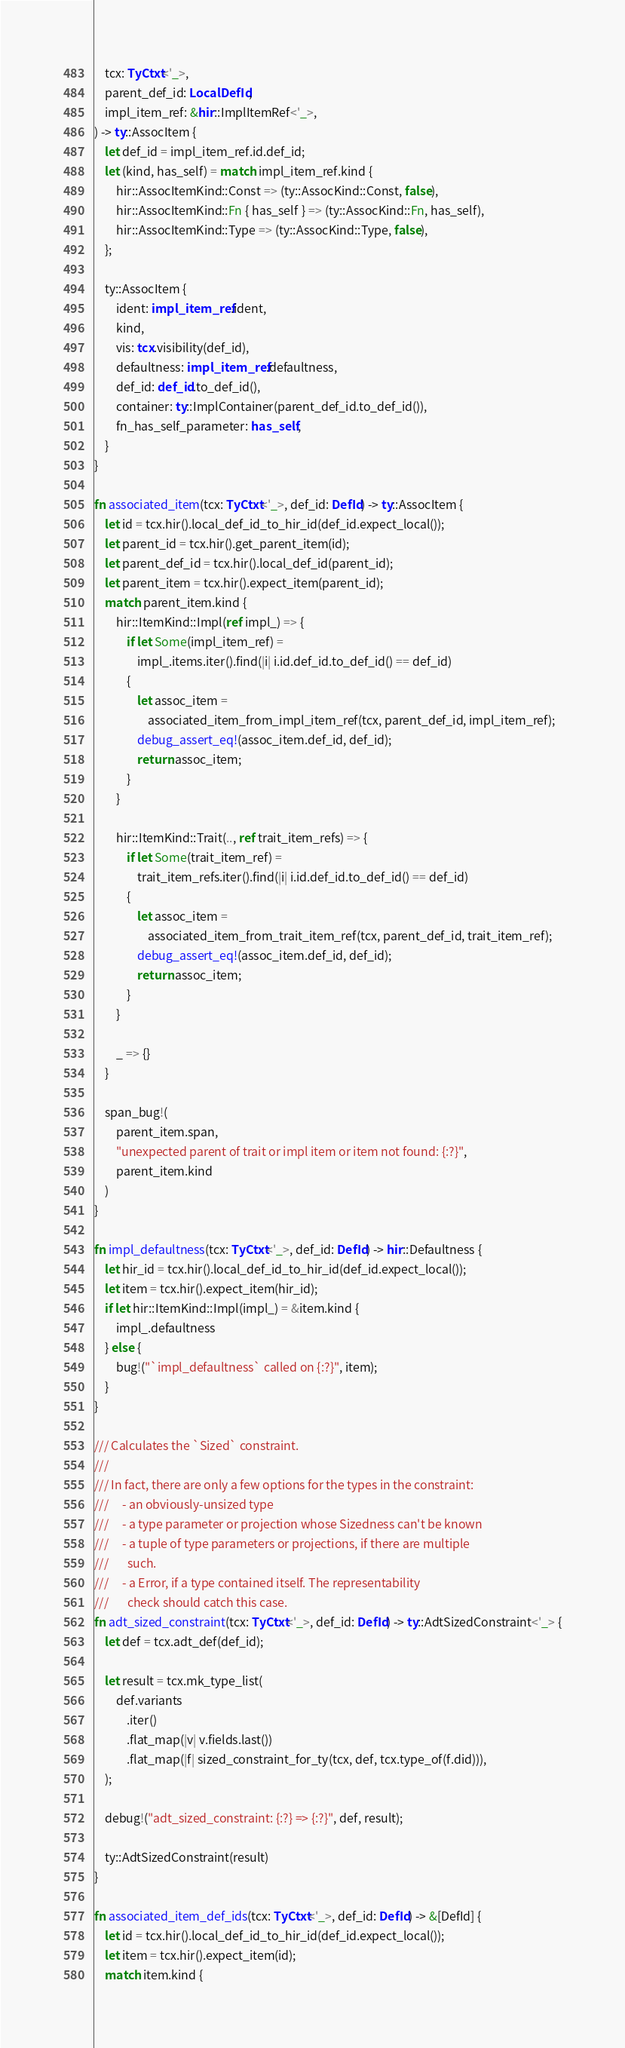Convert code to text. <code><loc_0><loc_0><loc_500><loc_500><_Rust_>    tcx: TyCtxt<'_>,
    parent_def_id: LocalDefId,
    impl_item_ref: &hir::ImplItemRef<'_>,
) -> ty::AssocItem {
    let def_id = impl_item_ref.id.def_id;
    let (kind, has_self) = match impl_item_ref.kind {
        hir::AssocItemKind::Const => (ty::AssocKind::Const, false),
        hir::AssocItemKind::Fn { has_self } => (ty::AssocKind::Fn, has_self),
        hir::AssocItemKind::Type => (ty::AssocKind::Type, false),
    };

    ty::AssocItem {
        ident: impl_item_ref.ident,
        kind,
        vis: tcx.visibility(def_id),
        defaultness: impl_item_ref.defaultness,
        def_id: def_id.to_def_id(),
        container: ty::ImplContainer(parent_def_id.to_def_id()),
        fn_has_self_parameter: has_self,
    }
}

fn associated_item(tcx: TyCtxt<'_>, def_id: DefId) -> ty::AssocItem {
    let id = tcx.hir().local_def_id_to_hir_id(def_id.expect_local());
    let parent_id = tcx.hir().get_parent_item(id);
    let parent_def_id = tcx.hir().local_def_id(parent_id);
    let parent_item = tcx.hir().expect_item(parent_id);
    match parent_item.kind {
        hir::ItemKind::Impl(ref impl_) => {
            if let Some(impl_item_ref) =
                impl_.items.iter().find(|i| i.id.def_id.to_def_id() == def_id)
            {
                let assoc_item =
                    associated_item_from_impl_item_ref(tcx, parent_def_id, impl_item_ref);
                debug_assert_eq!(assoc_item.def_id, def_id);
                return assoc_item;
            }
        }

        hir::ItemKind::Trait(.., ref trait_item_refs) => {
            if let Some(trait_item_ref) =
                trait_item_refs.iter().find(|i| i.id.def_id.to_def_id() == def_id)
            {
                let assoc_item =
                    associated_item_from_trait_item_ref(tcx, parent_def_id, trait_item_ref);
                debug_assert_eq!(assoc_item.def_id, def_id);
                return assoc_item;
            }
        }

        _ => {}
    }

    span_bug!(
        parent_item.span,
        "unexpected parent of trait or impl item or item not found: {:?}",
        parent_item.kind
    )
}

fn impl_defaultness(tcx: TyCtxt<'_>, def_id: DefId) -> hir::Defaultness {
    let hir_id = tcx.hir().local_def_id_to_hir_id(def_id.expect_local());
    let item = tcx.hir().expect_item(hir_id);
    if let hir::ItemKind::Impl(impl_) = &item.kind {
        impl_.defaultness
    } else {
        bug!("`impl_defaultness` called on {:?}", item);
    }
}

/// Calculates the `Sized` constraint.
///
/// In fact, there are only a few options for the types in the constraint:
///     - an obviously-unsized type
///     - a type parameter or projection whose Sizedness can't be known
///     - a tuple of type parameters or projections, if there are multiple
///       such.
///     - a Error, if a type contained itself. The representability
///       check should catch this case.
fn adt_sized_constraint(tcx: TyCtxt<'_>, def_id: DefId) -> ty::AdtSizedConstraint<'_> {
    let def = tcx.adt_def(def_id);

    let result = tcx.mk_type_list(
        def.variants
            .iter()
            .flat_map(|v| v.fields.last())
            .flat_map(|f| sized_constraint_for_ty(tcx, def, tcx.type_of(f.did))),
    );

    debug!("adt_sized_constraint: {:?} => {:?}", def, result);

    ty::AdtSizedConstraint(result)
}

fn associated_item_def_ids(tcx: TyCtxt<'_>, def_id: DefId) -> &[DefId] {
    let id = tcx.hir().local_def_id_to_hir_id(def_id.expect_local());
    let item = tcx.hir().expect_item(id);
    match item.kind {</code> 